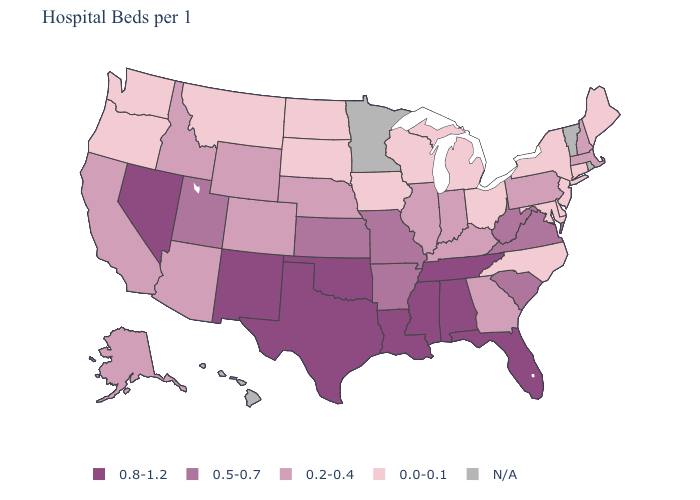Among the states that border Georgia , does North Carolina have the lowest value?
Short answer required. Yes. Among the states that border Maine , which have the highest value?
Quick response, please. New Hampshire. Which states have the highest value in the USA?
Short answer required. Alabama, Florida, Louisiana, Mississippi, Nevada, New Mexico, Oklahoma, Tennessee, Texas. Which states have the highest value in the USA?
Concise answer only. Alabama, Florida, Louisiana, Mississippi, Nevada, New Mexico, Oklahoma, Tennessee, Texas. Name the states that have a value in the range 0.0-0.1?
Write a very short answer. Connecticut, Delaware, Iowa, Maine, Maryland, Michigan, Montana, New Jersey, New York, North Carolina, North Dakota, Ohio, Oregon, South Dakota, Washington, Wisconsin. Which states have the highest value in the USA?
Give a very brief answer. Alabama, Florida, Louisiana, Mississippi, Nevada, New Mexico, Oklahoma, Tennessee, Texas. Name the states that have a value in the range 0.2-0.4?
Keep it brief. Alaska, Arizona, California, Colorado, Georgia, Idaho, Illinois, Indiana, Kentucky, Massachusetts, Nebraska, New Hampshire, Pennsylvania, Wyoming. Among the states that border Pennsylvania , which have the highest value?
Write a very short answer. West Virginia. Does Louisiana have the highest value in the South?
Be succinct. Yes. Name the states that have a value in the range N/A?
Be succinct. Hawaii, Minnesota, Rhode Island, Vermont. What is the value of Georgia?
Short answer required. 0.2-0.4. Which states have the highest value in the USA?
Give a very brief answer. Alabama, Florida, Louisiana, Mississippi, Nevada, New Mexico, Oklahoma, Tennessee, Texas. Is the legend a continuous bar?
Keep it brief. No. Name the states that have a value in the range 0.8-1.2?
Give a very brief answer. Alabama, Florida, Louisiana, Mississippi, Nevada, New Mexico, Oklahoma, Tennessee, Texas. 